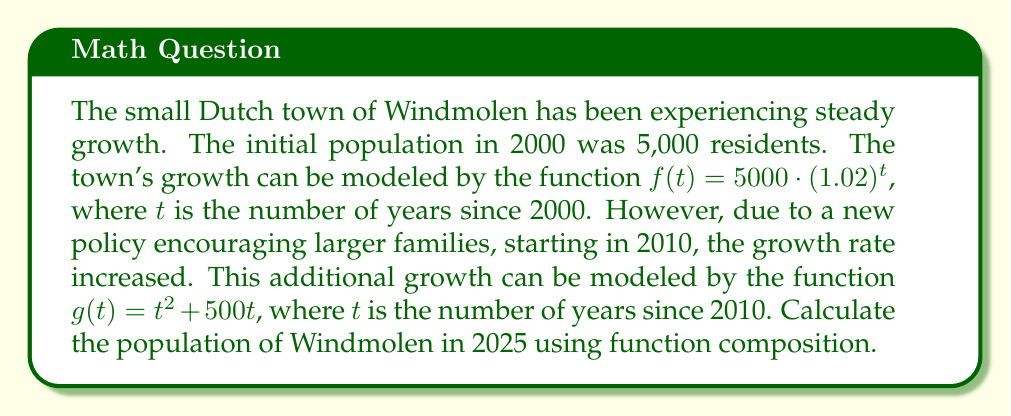Help me with this question. Let's approach this step-by-step:

1) First, we need to compose the functions $f$ and $g$. The composition will be $f(g(t))$, where $t$ represents the years since 2010.

2) For 2025, we need to calculate $t$:
   2025 - 2010 = 15 years

3) Now, let's calculate $g(15)$:
   $g(15) = 15^2 + 500 \cdot 15 = 225 + 7500 = 7725$

4) This result represents the additional years to be added to the original function $f$.

5) Now we can calculate $f(g(15))$:
   $f(g(15)) = f(7725) = 5000 \cdot (1.02)^{7725}$

6) Using a calculator (as this is a complex calculation):
   $5000 \cdot (1.02)^{7725} \approx 1,624,371,614$

7) Therefore, the population of Windmolen in 2025 will be approximately 1,624,371,614 residents.
Answer: $1,624,371,614$ 